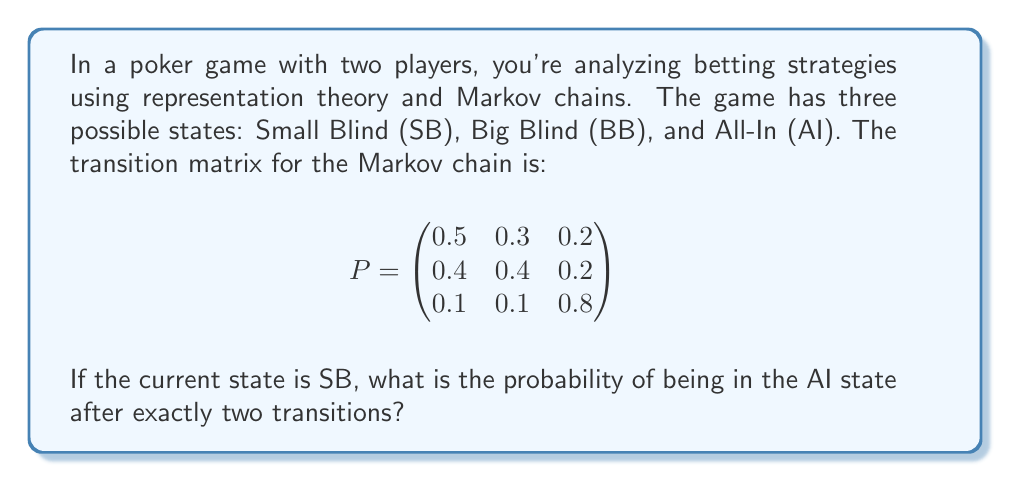What is the answer to this math problem? To solve this problem, we'll use the properties of Markov chains and matrix multiplication:

1) The given transition matrix $P$ represents the probabilities of moving from one state to another in a single transition.

2) To find the probability of being in a particular state after two transitions, we need to calculate $P^2$.

3) Let's multiply $P$ by itself:

   $$P^2 = \begin{pmatrix}
   0.5 & 0.3 & 0.2 \\
   0.4 & 0.4 & 0.2 \\
   0.1 & 0.1 & 0.8
   \end{pmatrix} \times \begin{pmatrix}
   0.5 & 0.3 & 0.2 \\
   0.4 & 0.4 & 0.2 \\
   0.1 & 0.1 & 0.8
   \end{pmatrix}$$

4) Performing the matrix multiplication:

   $$P^2 = \begin{pmatrix}
   0.41 & 0.31 & 0.28 \\
   0.42 & 0.32 & 0.26 \\
   0.17 & 0.15 & 0.68
   \end{pmatrix}$$

5) The question asks for the probability of being in the AI state (the third state) after two transitions, starting from the SB state (the first state).

6) This probability is given by the element in the first row, third column of $P^2$, which is 0.28.
Answer: 0.28 